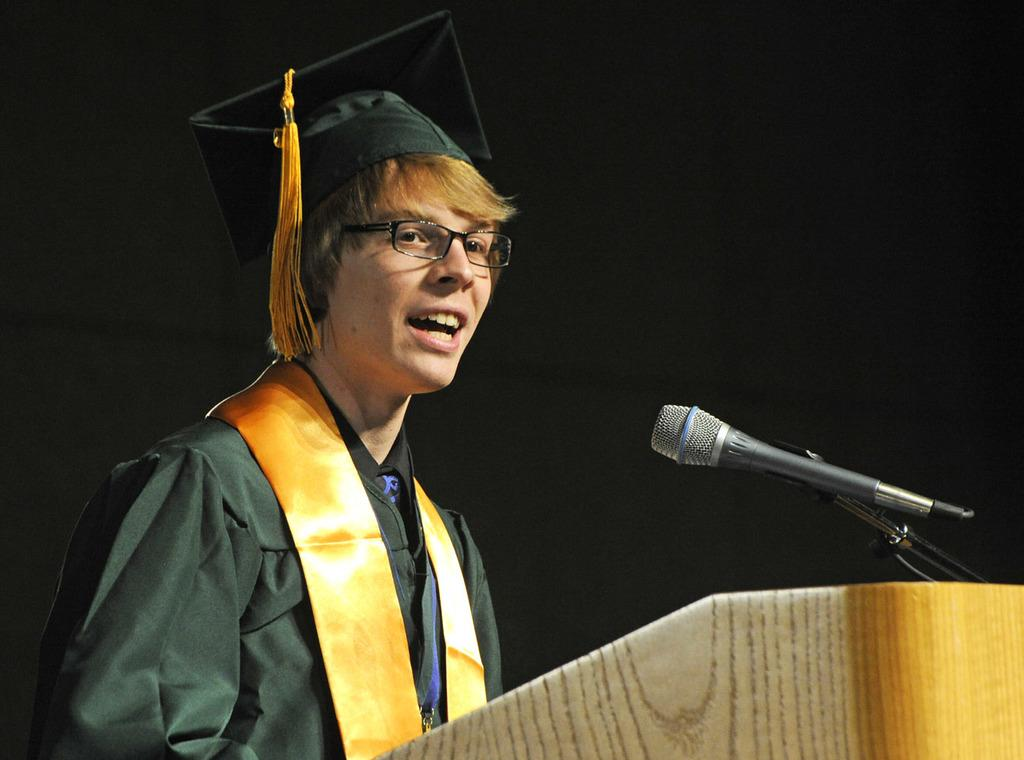What is the person in the image doing? The person is standing in front of a podium. What is on the podium? There is a mic on the podium. What can be observed about the background of the image? The background of the image is dark. What type of rice is being served on the podium? There is no rice present in the image; the podium has a mic on it. Can you see a kitty playing with the mic in the image? There is no kitty present in the image; only the person and the mic are visible. 